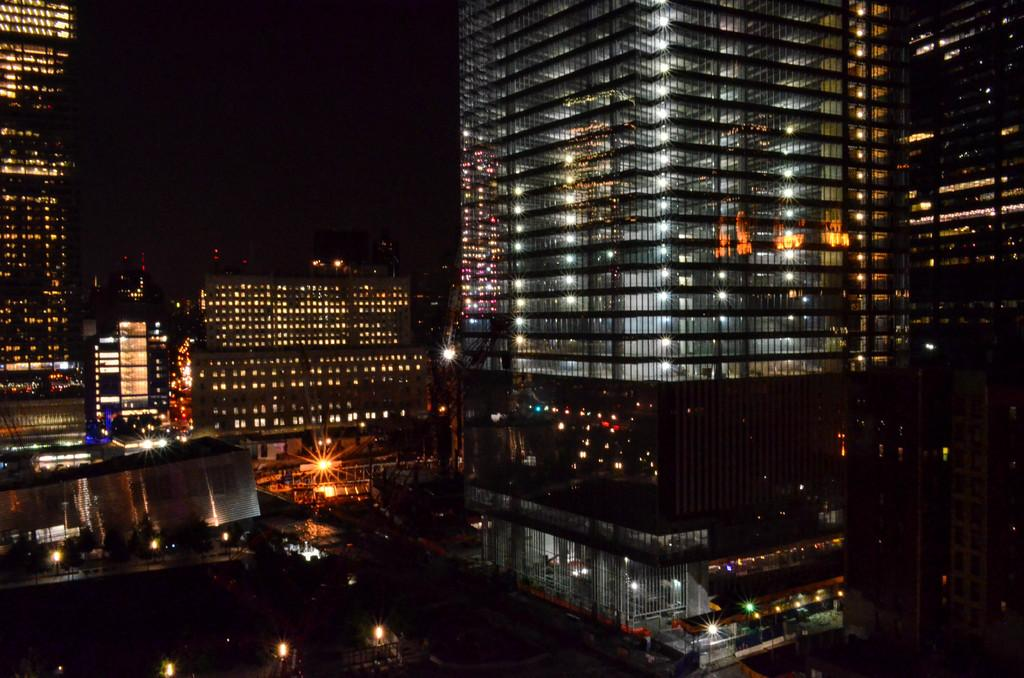What type of structures can be seen in the image? There are buildings in the image. What can be seen illuminating the scene in the image? There are lights in the image. What else is present in the image besides the buildings and lights? There are some objects in the image. What is the color of the background in the image? The background of the image is dark. What type of throne is visible in the image? There is no throne present in the image. What is the tendency of the objects in the image to move or change position? The objects in the image are stationary and do not exhibit any tendency to move or change position. 